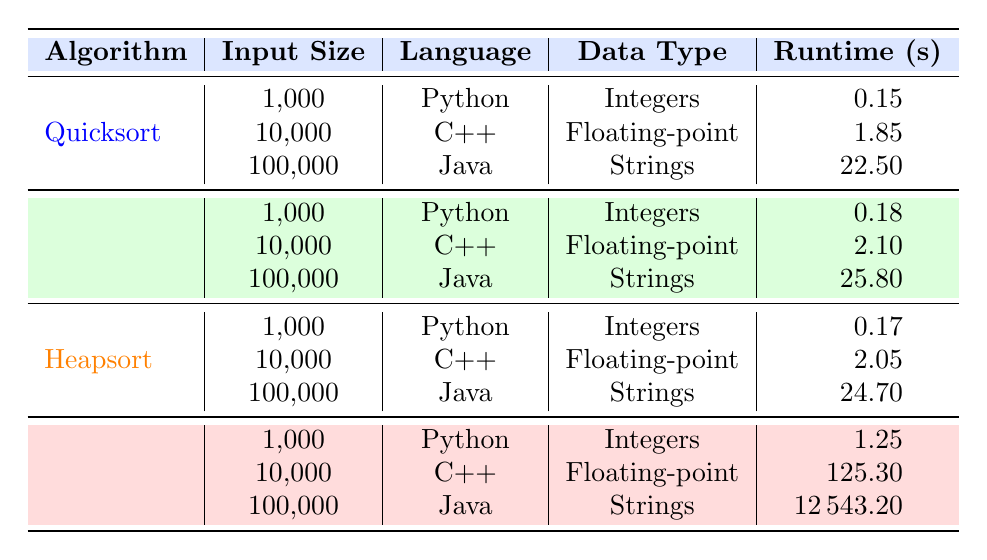What is the runtime of Mergesort with an input size of 10000? Mergesort's runtime for an input size of 10000 is specified in the table under the corresponding row where it states C++ as the language and Floating-point as the data type, which shows a runtime of 2.1 seconds.
Answer: 2.1 Which sorting algorithm has the lowest runtime when sorting 1000 integers? To find this, we look through the 1000 input size rows. The runtimes are 0.15 for Quicksort, 0.18 for Mergesort, 0.17 for Heapsort, and 1.25 for Bubblesort. Among these, Quicksort has the lowest runtime of 0.15 seconds.
Answer: Quicksort What is the average runtime for Bubblesort across all input sizes? Bubblesort has three runtimes: 1.25 for 1000, 125.30 for 10000, and 12543.20 for 100000. The sum of these runtimes is (1.25 + 125.30 + 12543.20) = 12669.75 seconds. There are 3 data points, so we divide that by 3: 12669.75 / 3 = 4223.25 seconds.
Answer: 4223.25 Is the space complexity of Heapsort always O(1)? From the table, Heapsort consistently has a space complexity of O(1) across all input sizes (1000, 10000, and 100000), confirming that the statement is true.
Answer: Yes Which algorithm takes the longest time to sort 100000 strings and what is that time? Looking at the 100000 input size, the algorithms listed are Quicksort (22.5 seconds), Mergesort (25.8 seconds), Heapsort (24.7 seconds), and Bubblesort (12543.20 seconds). Bubblesort has the longest runtime of 12543.20 seconds.
Answer: Bubblesort, 12543.20 seconds What is the difference in runtime between Quicksort and Heapsort when sorting 10000 floating-point numbers? The runtime for Quicksort is 1.85 seconds, and for Heapsort, it is 2.05 seconds. The difference is calculated as 2.05 - 1.85 = 0.20 seconds.
Answer: 0.20 seconds If the sum of all runtimes for Mergesort is taken, what is it? The runtimes for Mergesort are 0.18 for 1000, 2.10 for 10000, and 25.80 for 100000. Adding these gives us (0.18 + 2.10 + 25.80) = 28.08 seconds.
Answer: 28.08 seconds Which algorithm is the most efficient for sorting 1000 integers and why? The algorithm with the lowest runtime for sorting 1000 integers is Quicksort at 0.15 seconds. Efficiency is determined by the shortest runtime in this case, therefore, Quicksort is the most efficient.
Answer: Quicksort 